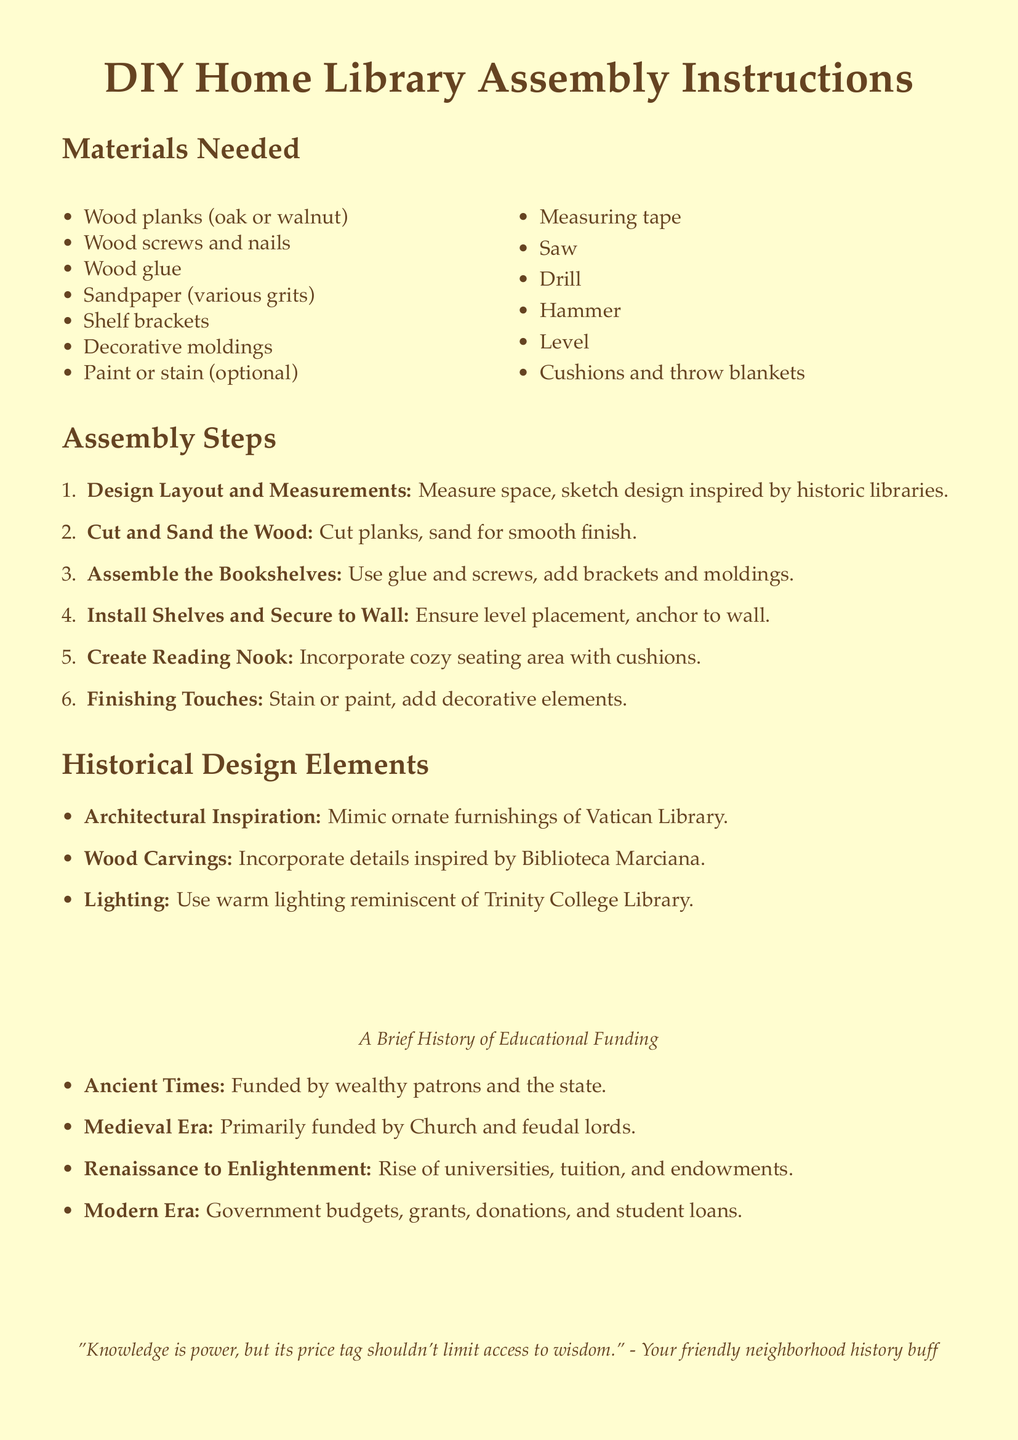What materials are needed for the DIY home library? The materials listed include wood planks, screws, glue, and several other items necessary for assembly.
Answer: Wood planks, screws, glue, sandpaper, shelf brackets, decorative moldings, paint or stain, measuring tape, saw, drill, hammer, level, cushions, throw blankets What is the first step in the assembly instructions? The first step outlined is to design the layout and take measurements of the available space.
Answer: Design Layout and Measurements Which historic library inspired the architectural elements in the design? The document mentions the Vatican Library as a source of architectural inspiration in the design elements.
Answer: Vatican Library What era saw the rise of universities and tuition fees? The Renaissance to Enlightenment period is noted for the increase in universities, tuition, and endowments.
Answer: Renaissance to Enlightenment How many assembly steps are outlined in the document? The document lists a total of six assembly steps for creating the DIY home library.
Answer: Six What decorative element is suggested to create a cozy reading nook? The instructions recommend using cushions and throw blankets to enhance comfort in the reading nook.
Answer: Cushions and throw blankets What type of wood is recommended for the bookshelves? The document suggests using wood planks made from oak or walnut for the bookshelves.
Answer: Oak or walnut What is the final touch suggested for the home library? The finishing touches involve staining or painting along with adding decorative elements to the library.
Answer: Stain or paint, decorative elements Who primarily funded educational initiatives in ancient times? It notes that funding in ancient times came from wealthy patrons and state resources.
Answer: Wealthy patrons and the state 